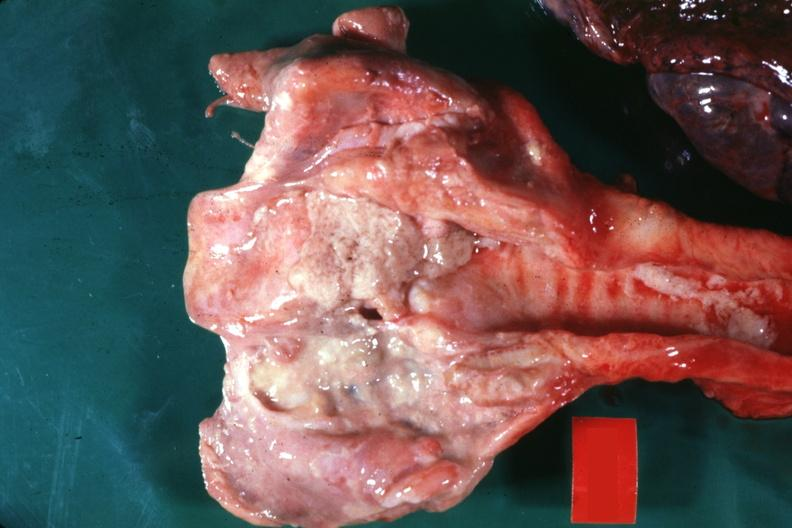s krukenberg tumor present?
Answer the question using a single word or phrase. No 